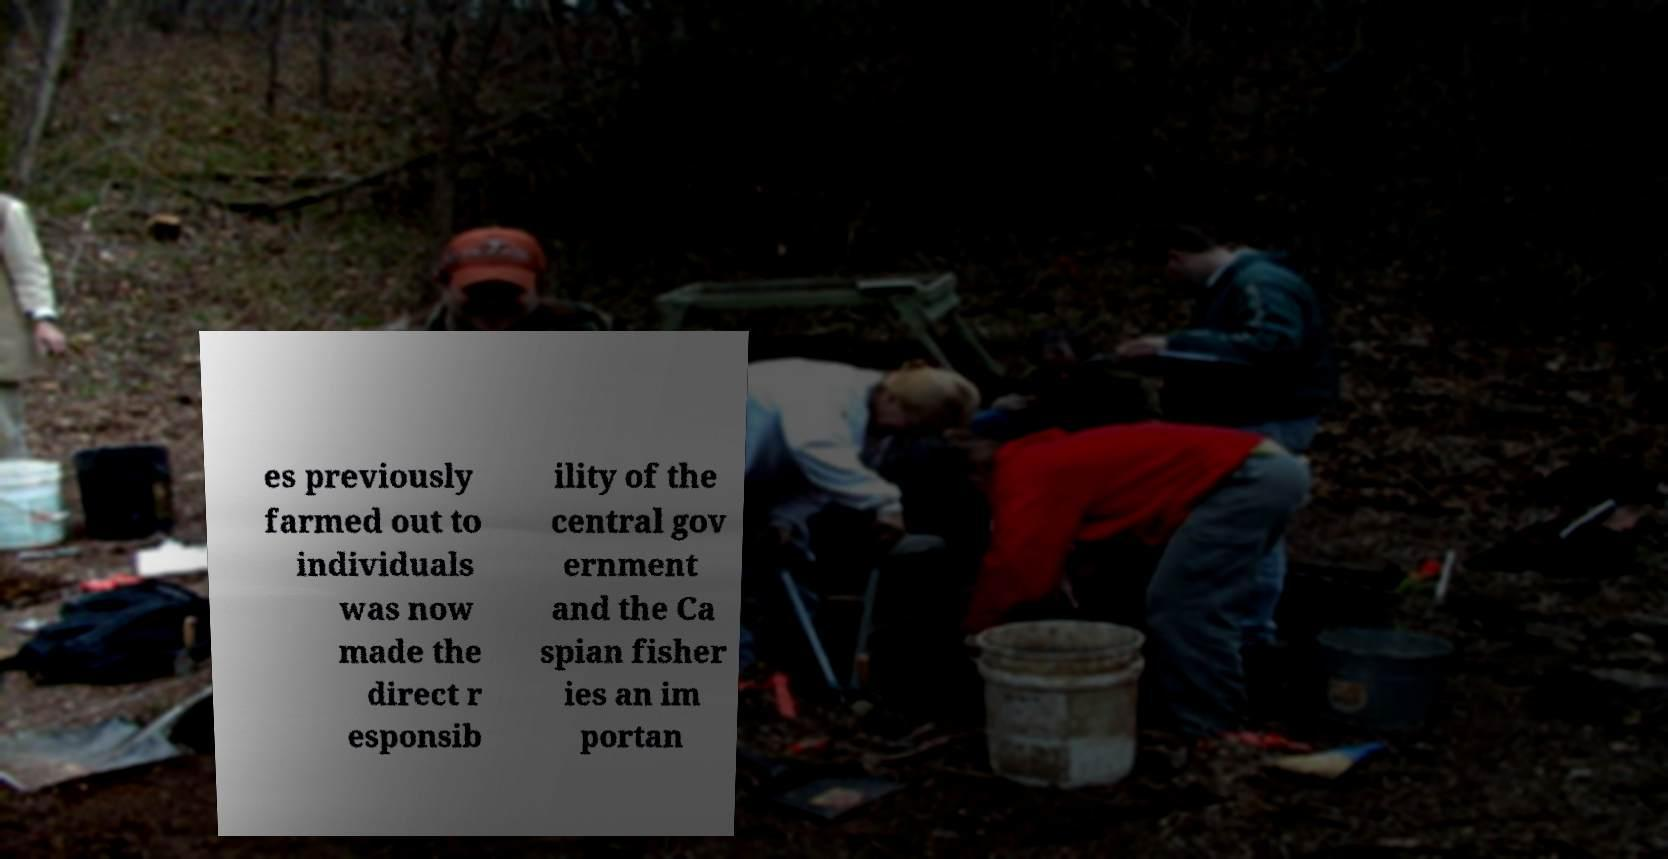Could you extract and type out the text from this image? es previously farmed out to individuals was now made the direct r esponsib ility of the central gov ernment and the Ca spian fisher ies an im portan 